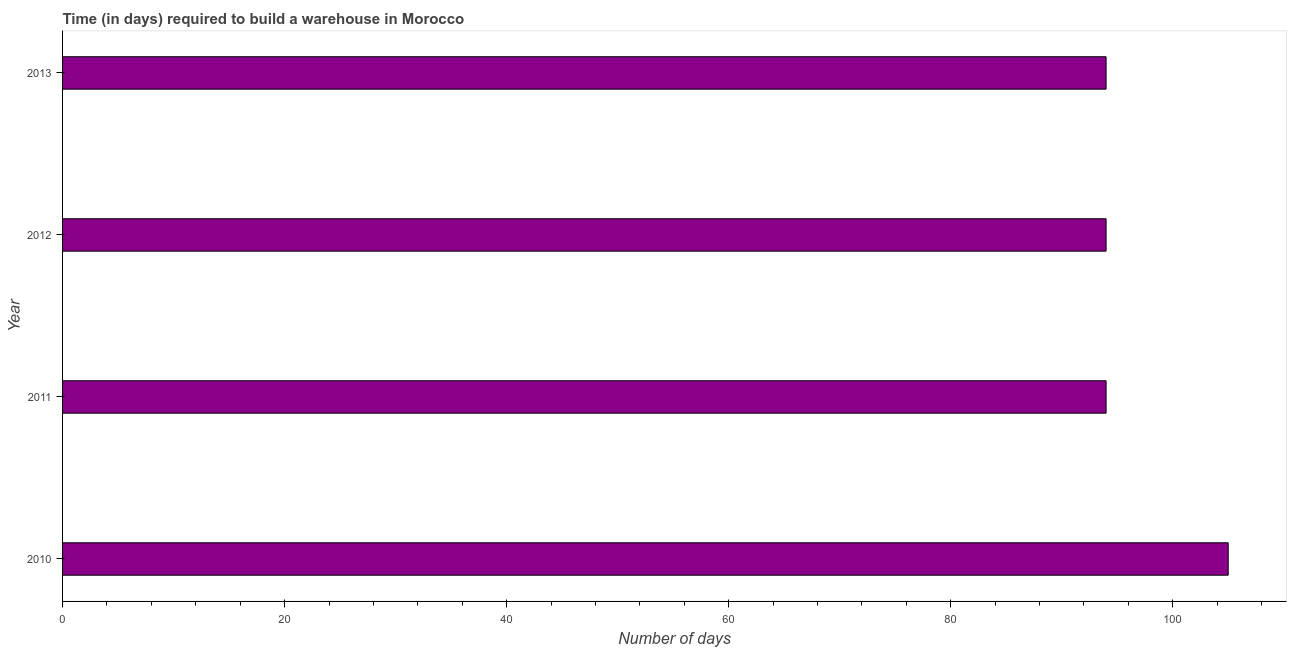Does the graph contain grids?
Provide a succinct answer. No. What is the title of the graph?
Provide a succinct answer. Time (in days) required to build a warehouse in Morocco. What is the label or title of the X-axis?
Offer a very short reply. Number of days. What is the label or title of the Y-axis?
Keep it short and to the point. Year. What is the time required to build a warehouse in 2013?
Your response must be concise. 94. Across all years, what is the maximum time required to build a warehouse?
Offer a terse response. 105. Across all years, what is the minimum time required to build a warehouse?
Make the answer very short. 94. In which year was the time required to build a warehouse maximum?
Your answer should be very brief. 2010. What is the sum of the time required to build a warehouse?
Your answer should be compact. 387. What is the difference between the time required to build a warehouse in 2012 and 2013?
Offer a very short reply. 0. What is the average time required to build a warehouse per year?
Your answer should be very brief. 96. What is the median time required to build a warehouse?
Your answer should be compact. 94. In how many years, is the time required to build a warehouse greater than 100 days?
Make the answer very short. 1. What is the difference between the highest and the second highest time required to build a warehouse?
Your answer should be very brief. 11. Are all the bars in the graph horizontal?
Give a very brief answer. Yes. What is the Number of days in 2010?
Offer a very short reply. 105. What is the Number of days in 2011?
Give a very brief answer. 94. What is the Number of days of 2012?
Give a very brief answer. 94. What is the Number of days in 2013?
Ensure brevity in your answer.  94. What is the difference between the Number of days in 2011 and 2012?
Keep it short and to the point. 0. What is the ratio of the Number of days in 2010 to that in 2011?
Your answer should be very brief. 1.12. What is the ratio of the Number of days in 2010 to that in 2012?
Your answer should be very brief. 1.12. What is the ratio of the Number of days in 2010 to that in 2013?
Offer a terse response. 1.12. What is the ratio of the Number of days in 2011 to that in 2012?
Your response must be concise. 1. What is the ratio of the Number of days in 2012 to that in 2013?
Provide a short and direct response. 1. 